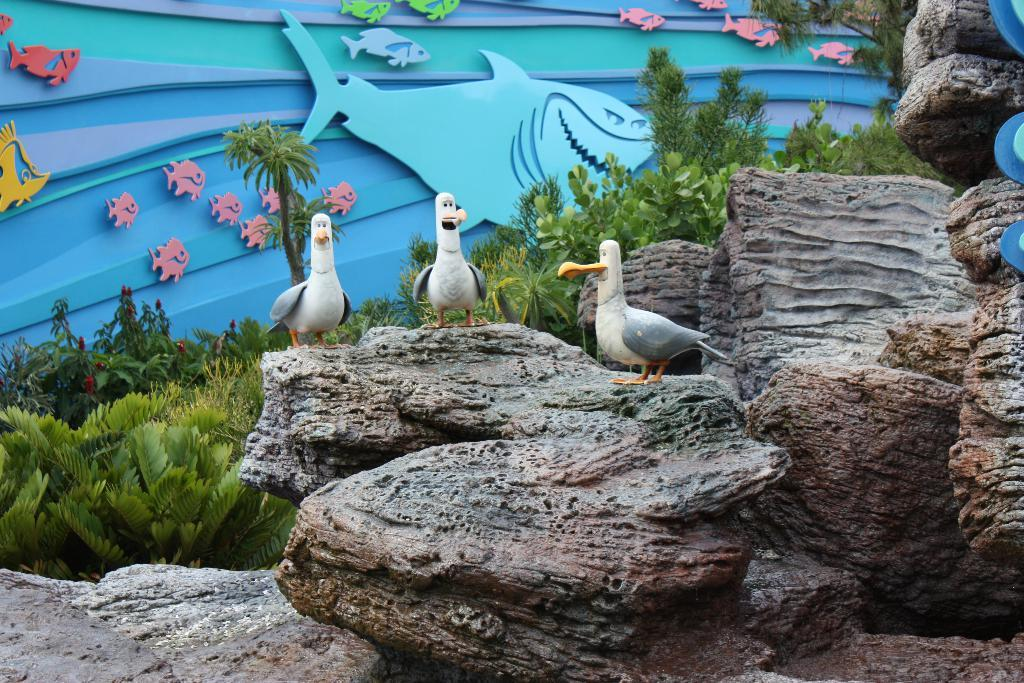What type of animals are depicted in the sculptures in the image? There are sculptures of birds in the image. What other natural elements can be seen in the image? There are rocks and plants visible in the image. What is located in the background of the image? There is a board in the background of the image. What is carved on the board? There is a fish carved on the board. What type of lace is used to decorate the birds in the image? There is no lace present in the image; the birds are depicted through sculptures. 